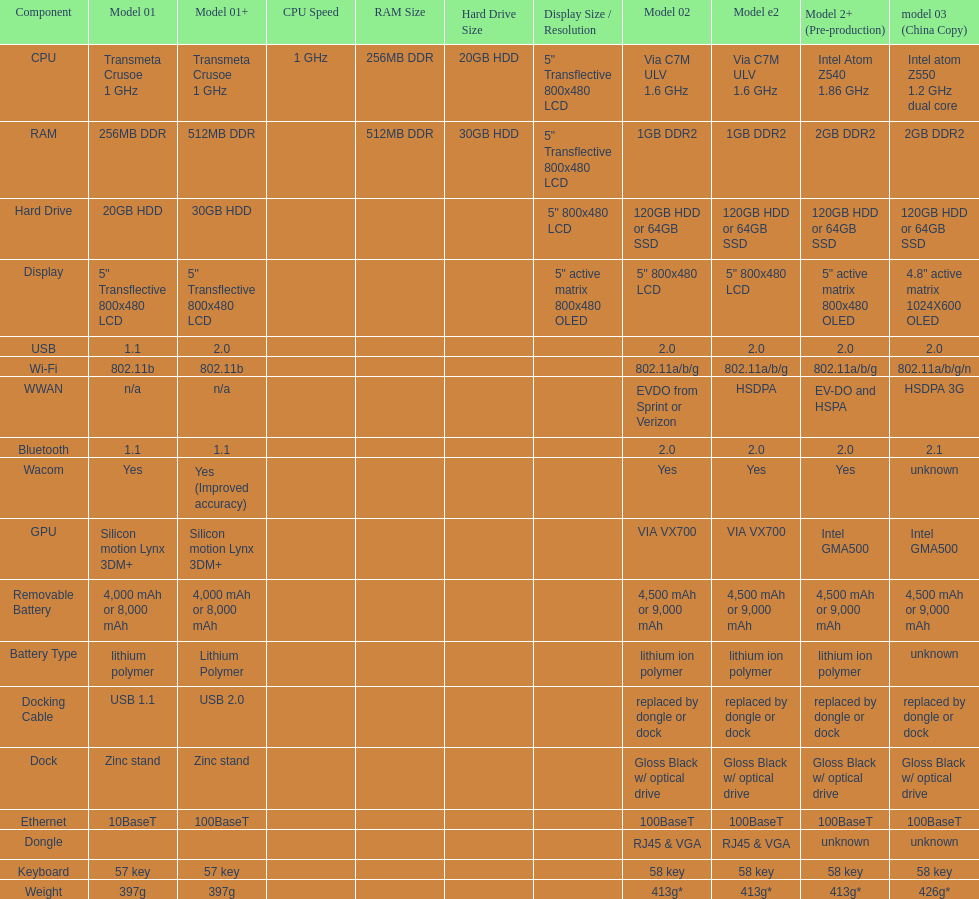Give me the full table as a dictionary. {'header': ['Component', 'Model 01', 'Model 01+', 'CPU Speed', 'RAM Size', 'Hard Drive Size', 'Display Size / Resolution', 'Model 02', 'Model e2', 'Model 2+ (Pre-production)', 'model 03 (China Copy)'], 'rows': [['CPU', 'Transmeta Crusoe 1\xa0GHz', 'Transmeta Crusoe 1\xa0GHz', '1\xa0GHz', '256MB DDR', '20GB HDD', '5" Transflective 800x480 LCD', 'Via C7M ULV 1.6\xa0GHz', 'Via C7M ULV 1.6\xa0GHz', 'Intel Atom Z540 1.86\xa0GHz', 'Intel atom Z550 1.2\xa0GHz dual core'], ['RAM', '256MB DDR', '512MB DDR', '', '512MB DDR', '30GB HDD', '5" Transflective 800x480 LCD', '1GB DDR2', '1GB DDR2', '2GB DDR2', '2GB DDR2'], ['Hard Drive', '20GB HDD', '30GB HDD', '', '', '', '5" 800x480 LCD', '120GB HDD or 64GB SSD', '120GB HDD or 64GB SSD', '120GB HDD or 64GB SSD', '120GB HDD or 64GB SSD'], ['Display', '5" Transflective 800x480 LCD', '5" Transflective 800x480 LCD', '', '', '', '5" active matrix 800x480 OLED', '5" 800x480 LCD', '5" 800x480 LCD', '5" active matrix 800x480 OLED', '4.8" active matrix 1024X600 OLED'], ['USB', '1.1', '2.0', '', '', '', '', '2.0', '2.0', '2.0', '2.0'], ['Wi-Fi', '802.11b', '802.11b', '', '', '', '', '802.11a/b/g', '802.11a/b/g', '802.11a/b/g', '802.11a/b/g/n'], ['WWAN', 'n/a', 'n/a', '', '', '', '', 'EVDO from Sprint or Verizon', 'HSDPA', 'EV-DO and HSPA', 'HSDPA 3G'], ['Bluetooth', '1.1', '1.1', '', '', '', '', '2.0', '2.0', '2.0', '2.1'], ['Wacom', 'Yes', 'Yes (Improved accuracy)', '', '', '', '', 'Yes', 'Yes', 'Yes', 'unknown'], ['GPU', 'Silicon motion Lynx 3DM+', 'Silicon motion Lynx 3DM+', '', '', '', '', 'VIA VX700', 'VIA VX700', 'Intel GMA500', 'Intel GMA500'], ['Removable Battery', '4,000 mAh or 8,000 mAh', '4,000 mAh or 8,000 mAh', '', '', '', '', '4,500 mAh or 9,000 mAh', '4,500 mAh or 9,000 mAh', '4,500 mAh or 9,000 mAh', '4,500 mAh or 9,000 mAh'], ['Battery Type', 'lithium polymer', 'Lithium Polymer', '', '', '', '', 'lithium ion polymer', 'lithium ion polymer', 'lithium ion polymer', 'unknown'], ['Docking Cable', 'USB 1.1', 'USB 2.0', '', '', '', '', 'replaced by dongle or dock', 'replaced by dongle or dock', 'replaced by dongle or dock', 'replaced by dongle or dock'], ['Dock', 'Zinc stand', 'Zinc stand', '', '', '', '', 'Gloss Black w/ optical drive', 'Gloss Black w/ optical drive', 'Gloss Black w/ optical drive', 'Gloss Black w/ optical drive'], ['Ethernet', '10BaseT', '100BaseT', '', '', '', '', '100BaseT', '100BaseT', '100BaseT', '100BaseT'], ['Dongle', '', '', '', '', '', '', 'RJ45 & VGA', 'RJ45 & VGA', 'unknown', 'unknown'], ['Keyboard', '57 key', '57 key', '', '', '', '', '58 key', '58 key', '58 key', '58 key'], ['Weight', '397g', '397g', '', '', '', '', '413g*', '413g*', '413g*', '426g*']]} How many models feature 2. 